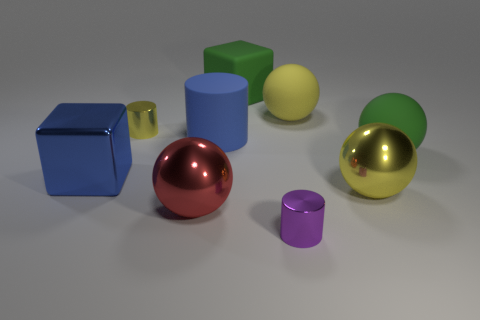How many other objects are there of the same color as the shiny cube?
Offer a very short reply. 1. What is the size of the yellow object that is made of the same material as the yellow cylinder?
Your answer should be compact. Large. The blue matte object has what size?
Your response must be concise. Large. Are the big red thing and the green ball made of the same material?
Offer a very short reply. No. How many spheres are large blue rubber objects or yellow metallic objects?
Give a very brief answer. 1. What is the color of the big metallic sphere that is on the left side of the blue thing that is to the right of the metallic block?
Provide a short and direct response. Red. What size is the rubber object that is the same color as the metal cube?
Offer a terse response. Large. What number of large yellow metal spheres are right of the metal cylinder that is on the right side of the blue thing that is to the right of the small yellow cylinder?
Give a very brief answer. 1. There is a big rubber thing that is right of the yellow rubber thing; does it have the same shape as the green matte thing left of the purple metal object?
Your response must be concise. No. How many objects are large red matte spheres or green matte objects?
Your answer should be compact. 2. 